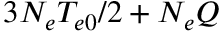Convert formula to latex. <formula><loc_0><loc_0><loc_500><loc_500>3 N _ { e } T _ { e 0 } / 2 + N _ { e } Q</formula> 